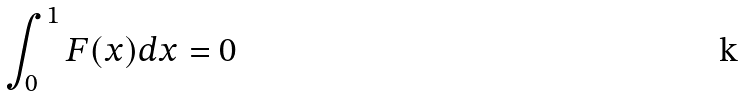<formula> <loc_0><loc_0><loc_500><loc_500>\int _ { 0 } ^ { 1 } F ( x ) d x = 0</formula> 